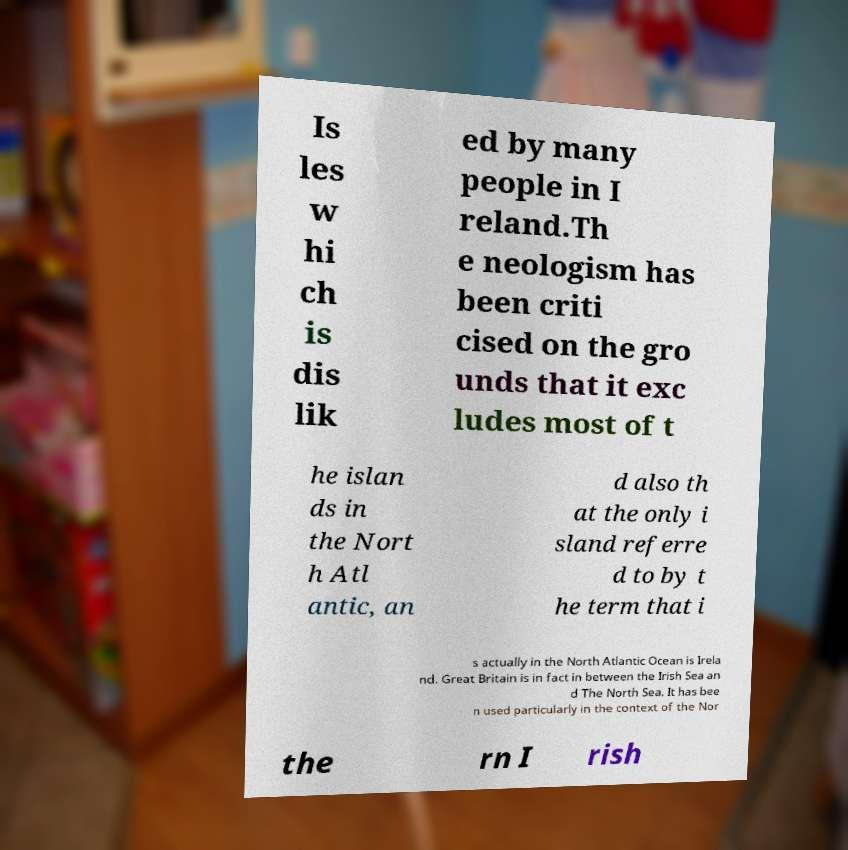Could you extract and type out the text from this image? Is les w hi ch is dis lik ed by many people in I reland.Th e neologism has been criti cised on the gro unds that it exc ludes most of t he islan ds in the Nort h Atl antic, an d also th at the only i sland referre d to by t he term that i s actually in the North Atlantic Ocean is Irela nd. Great Britain is in fact in between the Irish Sea an d The North Sea. It has bee n used particularly in the context of the Nor the rn I rish 